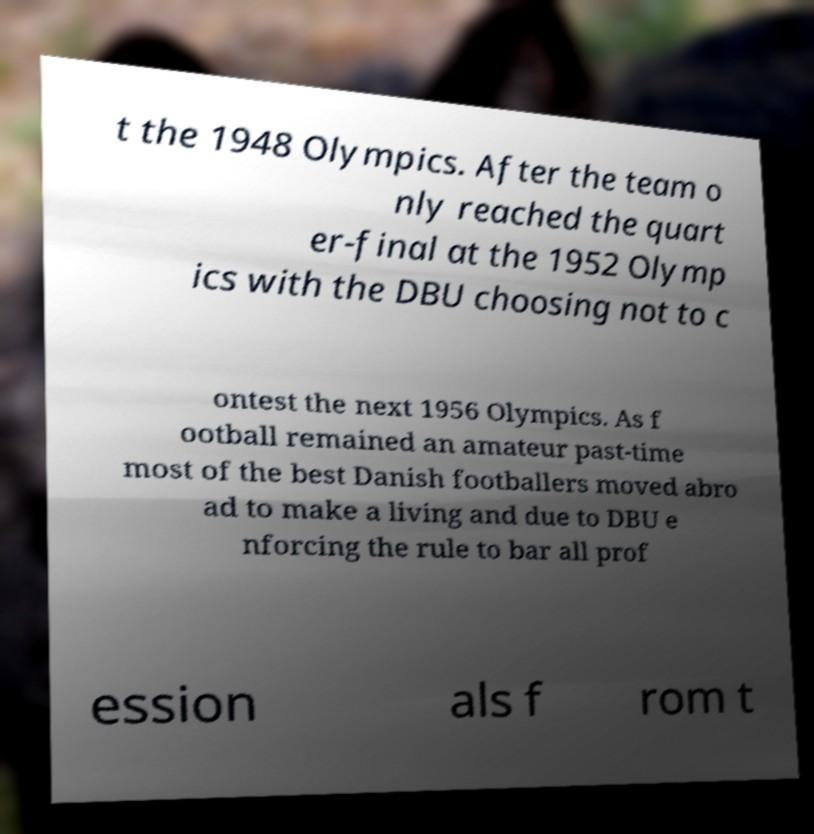Please read and relay the text visible in this image. What does it say? t the 1948 Olympics. After the team o nly reached the quart er-final at the 1952 Olymp ics with the DBU choosing not to c ontest the next 1956 Olympics. As f ootball remained an amateur past-time most of the best Danish footballers moved abro ad to make a living and due to DBU e nforcing the rule to bar all prof ession als f rom t 